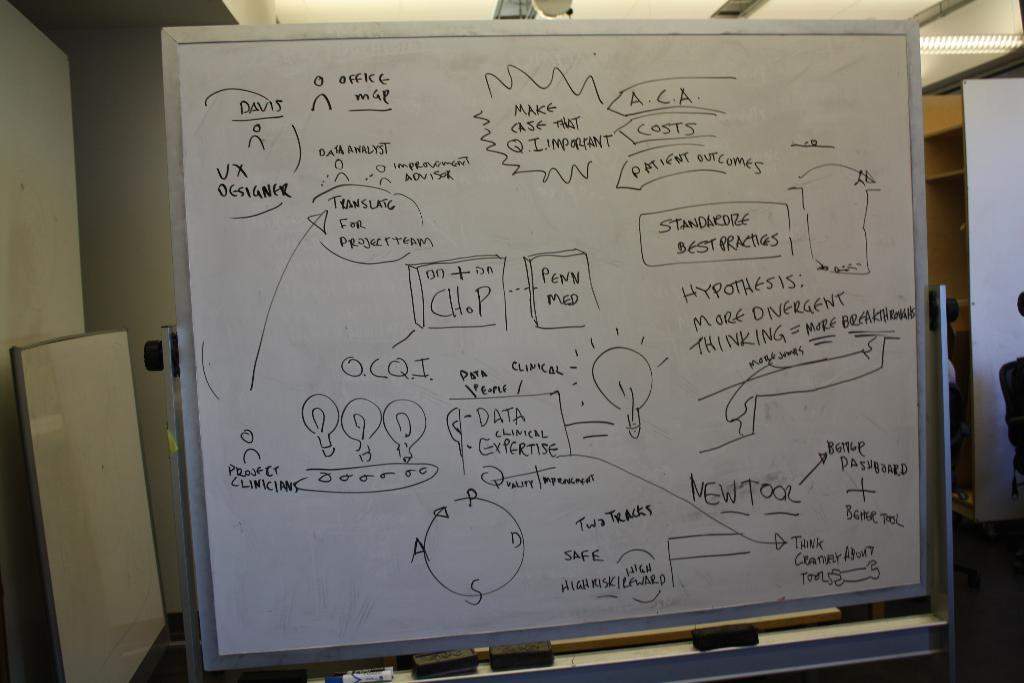Provide a one-sentence caption for the provided image. A whiteboard has text talking about patient outcomes and data. 